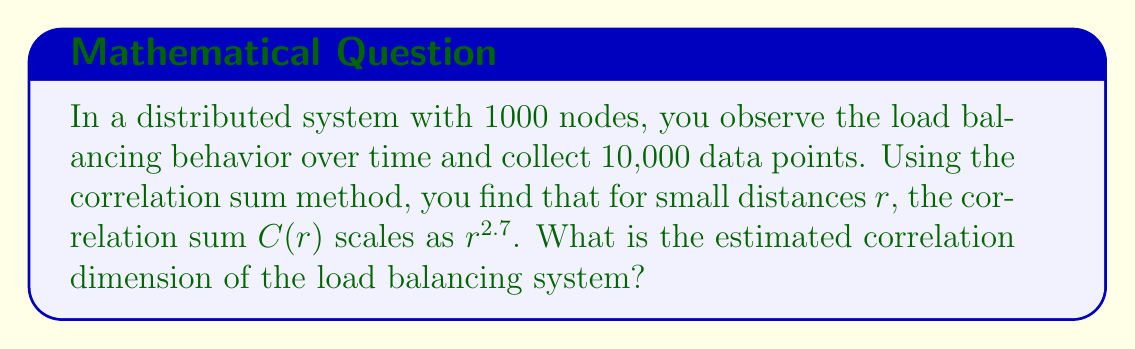Give your solution to this math problem. To determine the correlation dimension of the load balancing system, we need to understand the relationship between the correlation sum $C(r)$ and the distance $r$. The correlation dimension is defined as the scaling exponent in this relationship.

Step 1: Recall the definition of correlation dimension.
The correlation dimension $D_2$ is given by:

$$D_2 = \lim_{r \to 0} \frac{\log C(r)}{\log r}$$

Step 2: Analyze the given information.
We are told that for small distances $r$, $C(r)$ scales as $r^{2.7}$. This means:

$$C(r) \propto r^{2.7}$$

Step 3: Take the logarithm of both sides.
$$\log C(r) \propto 2.7 \log r$$

Step 4: Apply the definition of correlation dimension.
$$D_2 = \lim_{r \to 0} \frac{\log C(r)}{\log r} = 2.7$$

Therefore, the estimated correlation dimension of the load balancing system is 2.7.
Answer: 2.7 